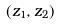Convert formula to latex. <formula><loc_0><loc_0><loc_500><loc_500>( z _ { 1 } , z _ { 2 } )</formula> 